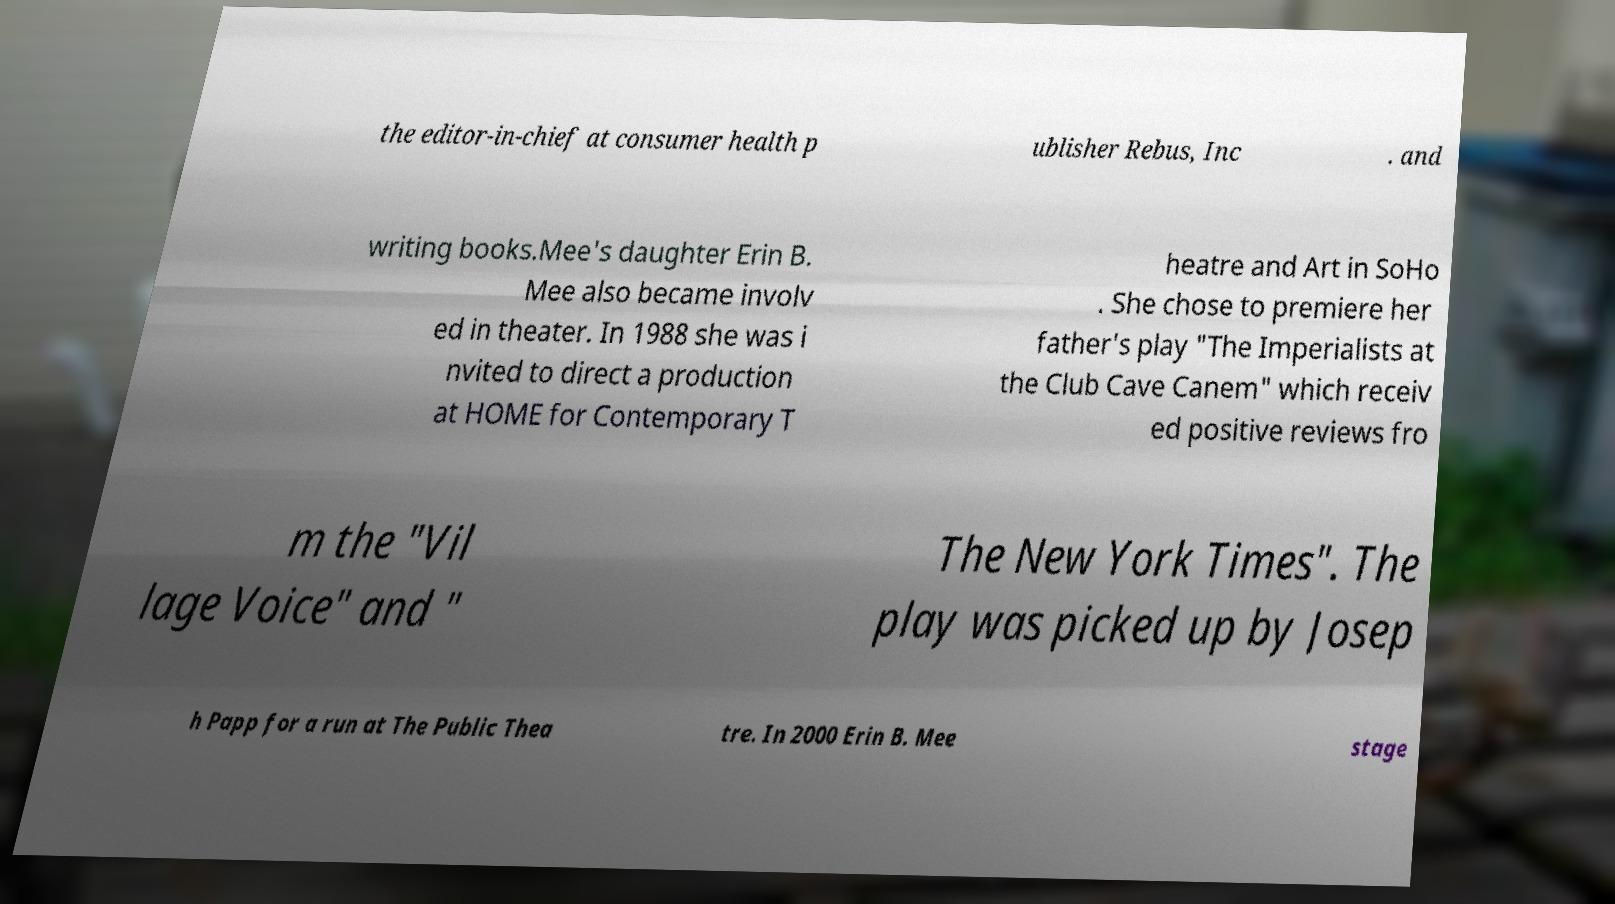Please identify and transcribe the text found in this image. the editor-in-chief at consumer health p ublisher Rebus, Inc . and writing books.Mee's daughter Erin B. Mee also became involv ed in theater. In 1988 she was i nvited to direct a production at HOME for Contemporary T heatre and Art in SoHo . She chose to premiere her father's play "The Imperialists at the Club Cave Canem" which receiv ed positive reviews fro m the "Vil lage Voice" and " The New York Times". The play was picked up by Josep h Papp for a run at The Public Thea tre. In 2000 Erin B. Mee stage 